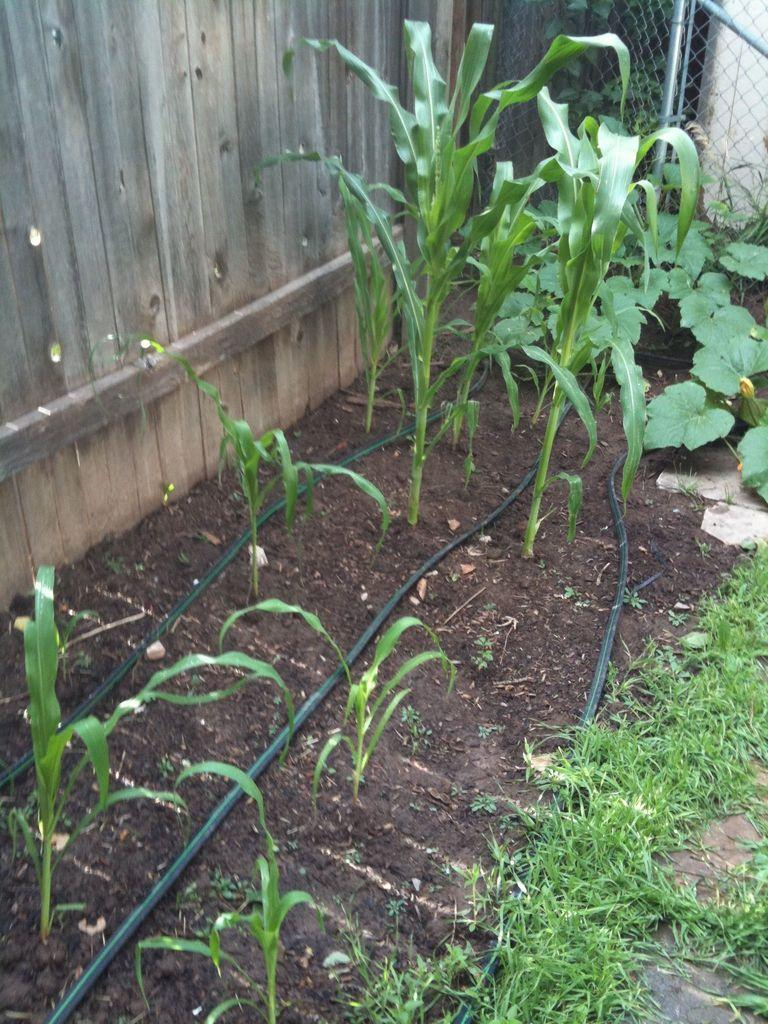What type of living organisms can be seen in the image? Plants can be seen in the image. What man-made structures are present in the image? Pipes and fencing are present in the image. What type of wall can be seen in the background of the image? There is a wooden wall in the background of the image. What type of legal advice is being given in the image? There is no lawyer or legal advice present in the image. Is the image set in space? No, the image is not set in space; it features plants, pipes, a wooden wall, and fencing. 